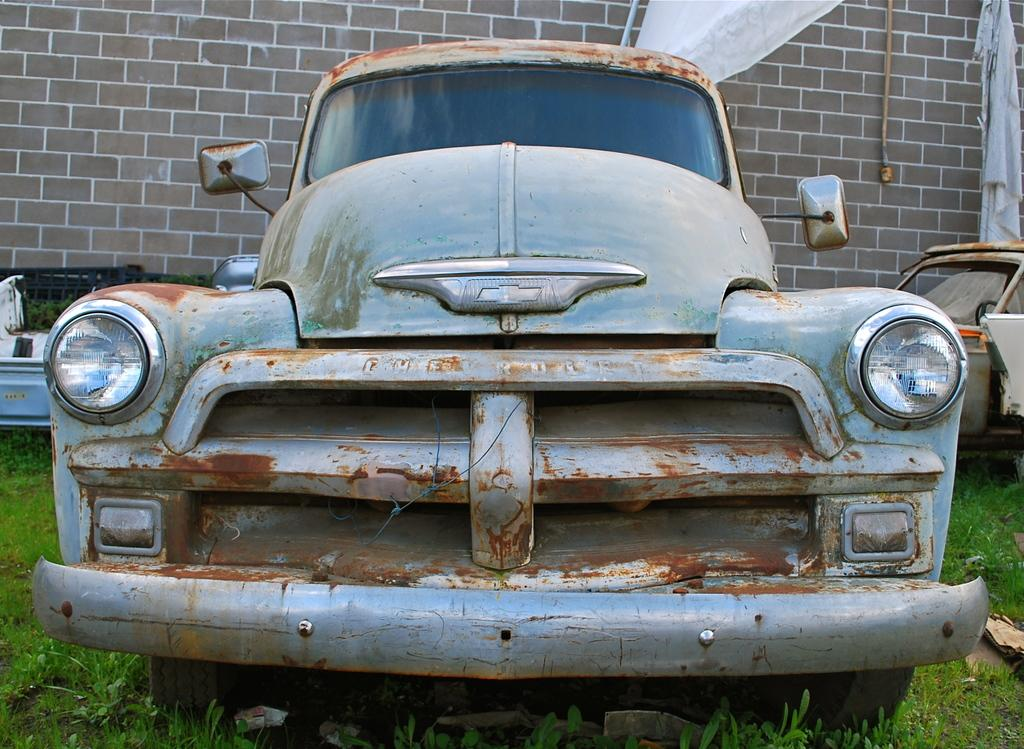What is the main subject in the middle of the image? There is an old car in the middle of the image. What else can be seen on the right side of the image? There is a vehicle on the right side of the image. What type of vegetation is present at the bottom of the image? There are plants at the bottom of the image. What can be seen in the background of the image? There is a wall visible in the background of the image. What type of writing can be seen on the basin in the image? There is no basin present in the image, so no writing can be observed. 